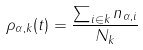<formula> <loc_0><loc_0><loc_500><loc_500>\rho _ { \alpha , k } ( t ) = \frac { \sum _ { i \in k } n _ { \alpha , i } } { N _ { k } }</formula> 